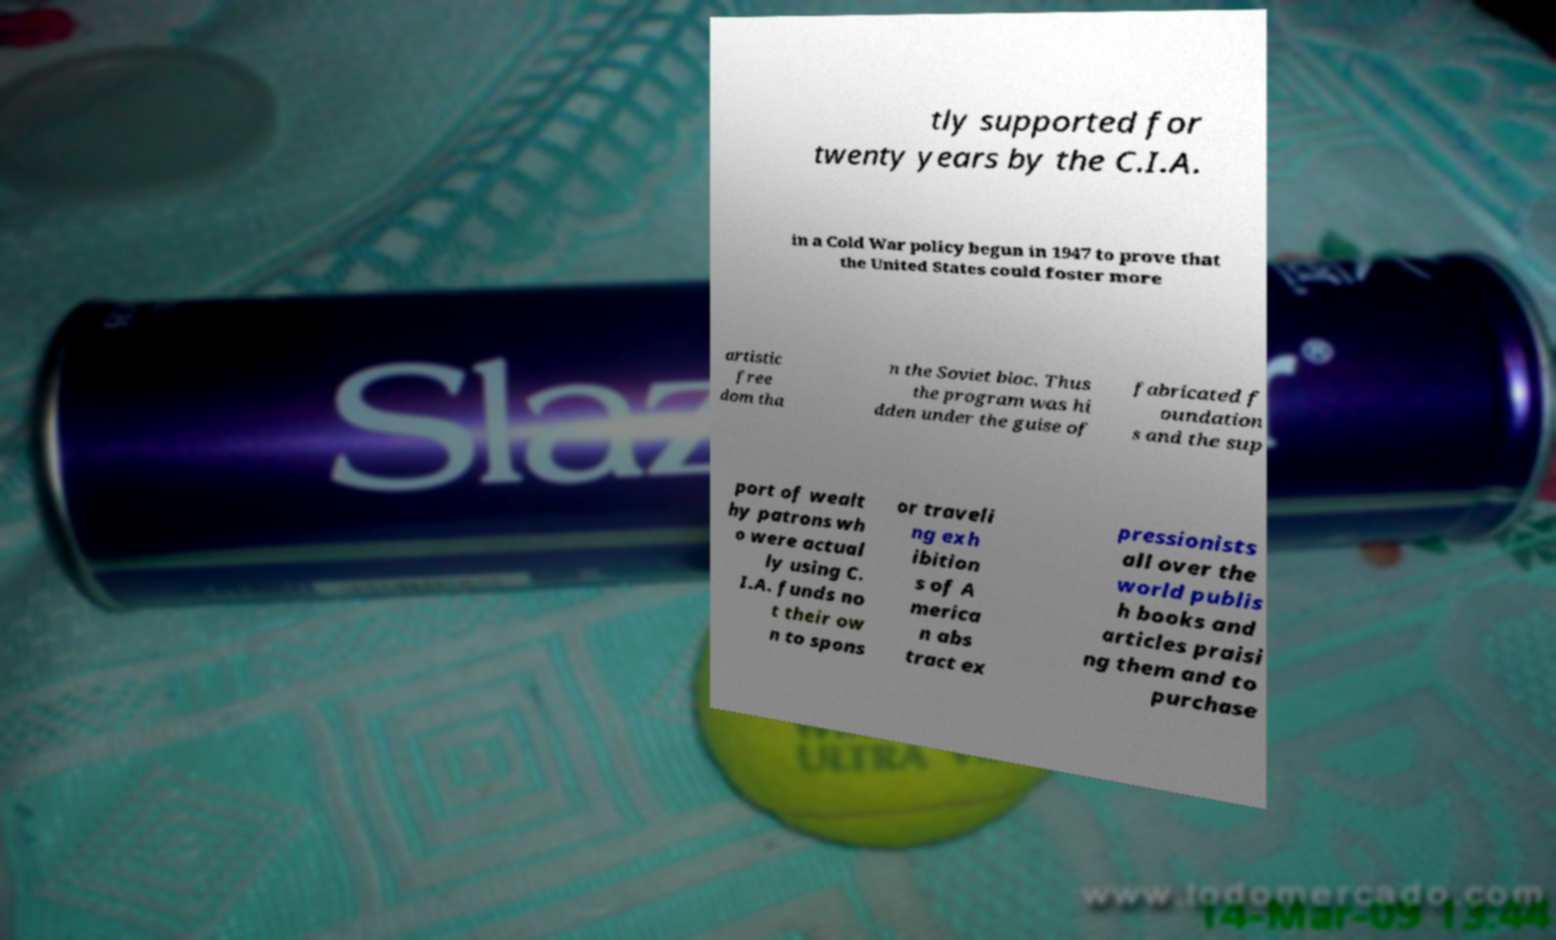Can you read and provide the text displayed in the image?This photo seems to have some interesting text. Can you extract and type it out for me? tly supported for twenty years by the C.I.A. in a Cold War policy begun in 1947 to prove that the United States could foster more artistic free dom tha n the Soviet bloc. Thus the program was hi dden under the guise of fabricated f oundation s and the sup port of wealt hy patrons wh o were actual ly using C. I.A. funds no t their ow n to spons or traveli ng exh ibition s of A merica n abs tract ex pressionists all over the world publis h books and articles praisi ng them and to purchase 